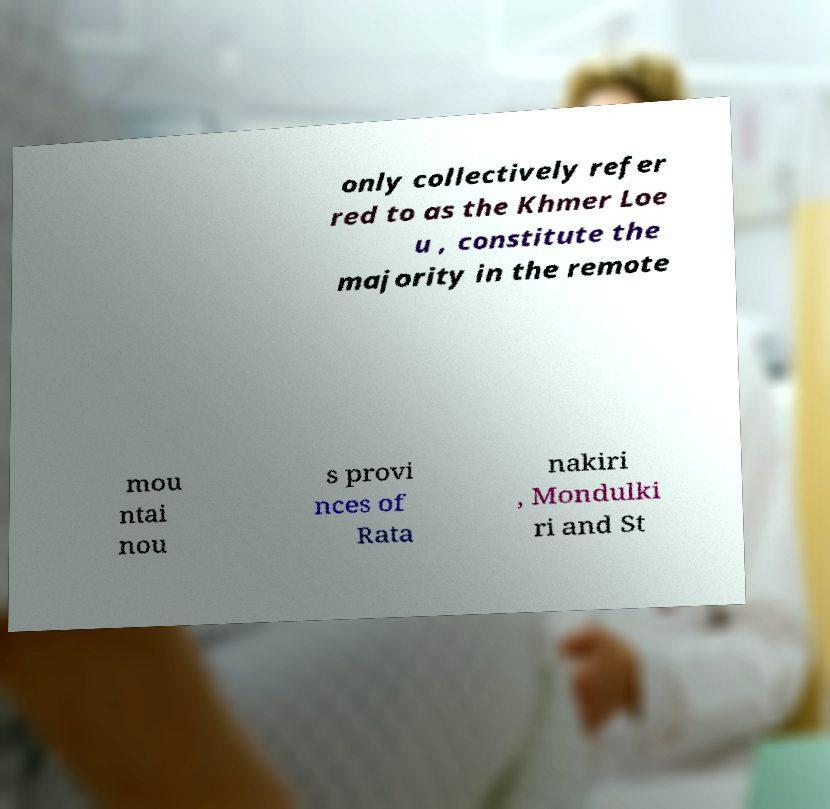I need the written content from this picture converted into text. Can you do that? only collectively refer red to as the Khmer Loe u , constitute the majority in the remote mou ntai nou s provi nces of Rata nakiri , Mondulki ri and St 